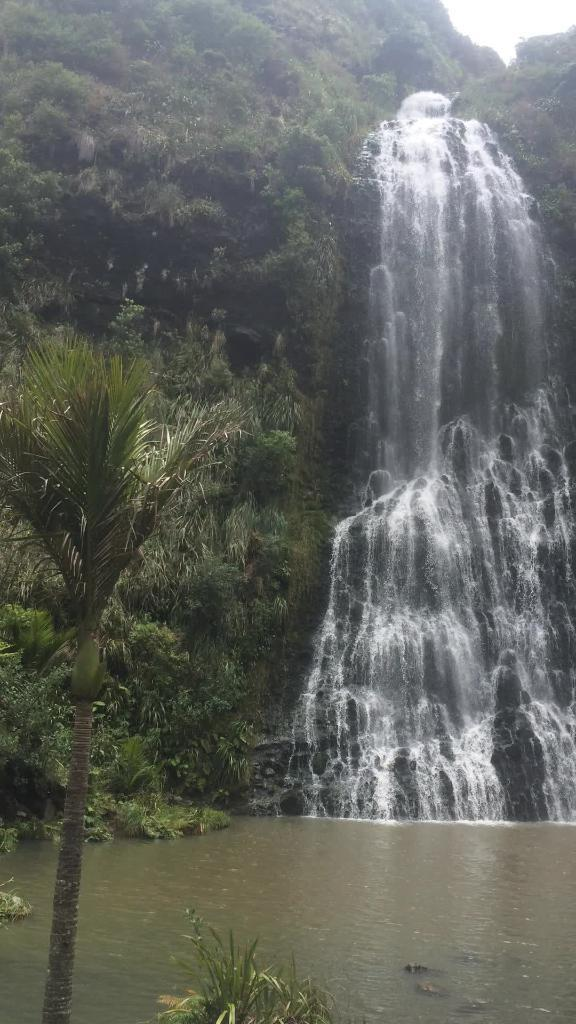What natural feature is the main subject of the image? There is a waterfall in the image. What type of vegetation is present near the waterfall? There are trees beside the waterfall. What is located in front of the image? There is a tree in front of the image. What other types of vegetation are present in the image? There are plants in front of the image. What is the primary substance visible in the image? There is water visible in the image. Can you see anyone slipping on a rose in the image? There is no person slipping on a rose in the image, nor is there a rose present. 